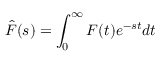Convert formula to latex. <formula><loc_0><loc_0><loc_500><loc_500>\hat { F } ( s ) = \int _ { 0 } ^ { \infty } F ( t ) e ^ { - s t } d t</formula> 